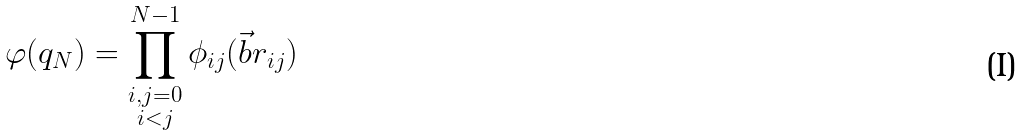Convert formula to latex. <formula><loc_0><loc_0><loc_500><loc_500>\varphi ( q _ { N } ) = \prod ^ { N - 1 } _ { \substack { i , j = 0 \\ i < j } } \phi _ { i j } ( \vec { b } { r } _ { i j } )</formula> 